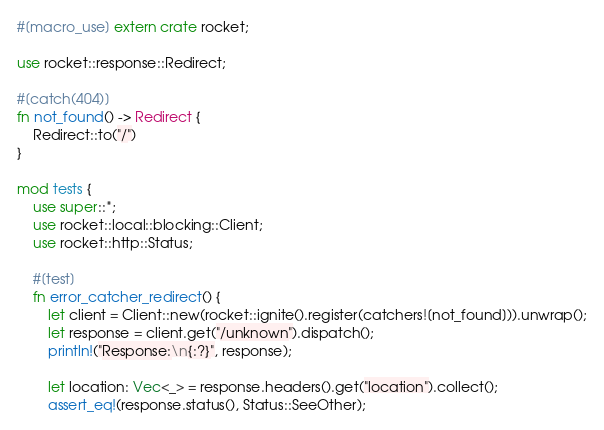<code> <loc_0><loc_0><loc_500><loc_500><_Rust_>#[macro_use] extern crate rocket;

use rocket::response::Redirect;

#[catch(404)]
fn not_found() -> Redirect {
    Redirect::to("/")
}

mod tests {
    use super::*;
    use rocket::local::blocking::Client;
    use rocket::http::Status;

    #[test]
    fn error_catcher_redirect() {
        let client = Client::new(rocket::ignite().register(catchers![not_found])).unwrap();
        let response = client.get("/unknown").dispatch();
        println!("Response:\n{:?}", response);

        let location: Vec<_> = response.headers().get("location").collect();
        assert_eq!(response.status(), Status::SeeOther);</code> 